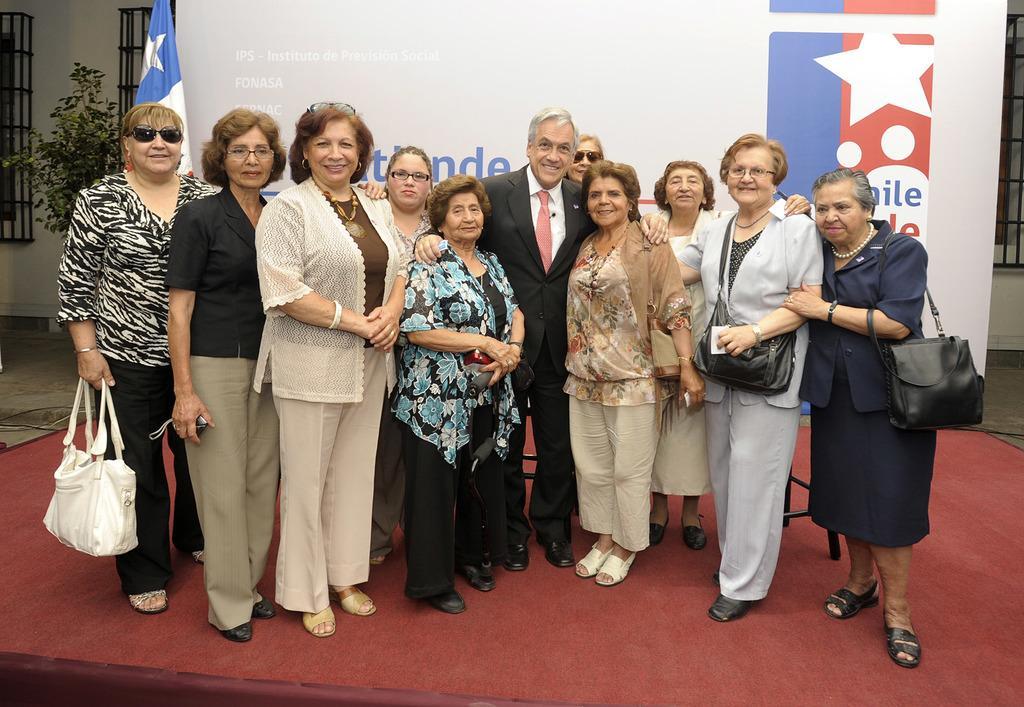Please provide a concise description of this image. In the center of the image we can see some persons are standing and some of them are carrying bags. In the background of the image we can see board, flag, plant, grills, wall. At the bottom of the image there is a carpet. On the left side of the image there is a floor. 